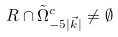<formula> <loc_0><loc_0><loc_500><loc_500>R \cap \tilde { \Omega } _ { - 5 | \vec { k } | } ^ { c } \neq \emptyset</formula> 